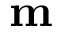Convert formula to latex. <formula><loc_0><loc_0><loc_500><loc_500>m</formula> 